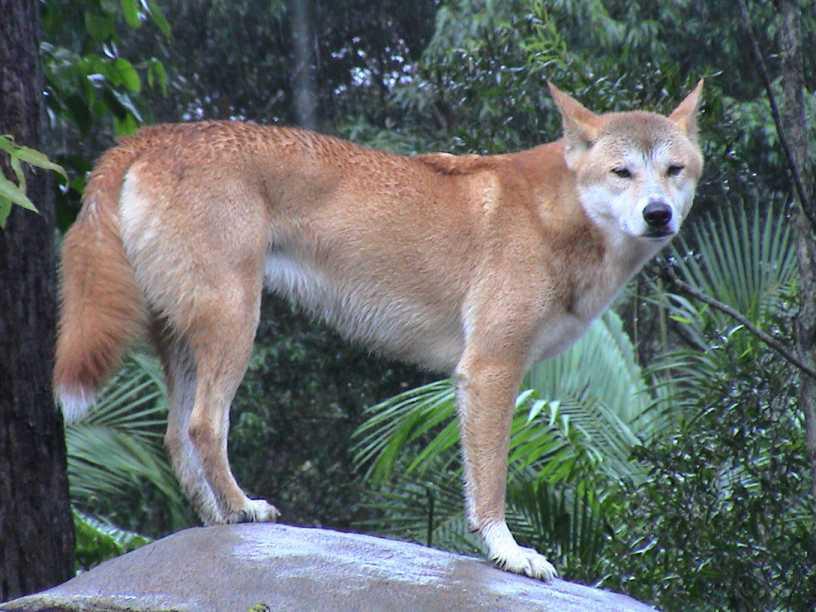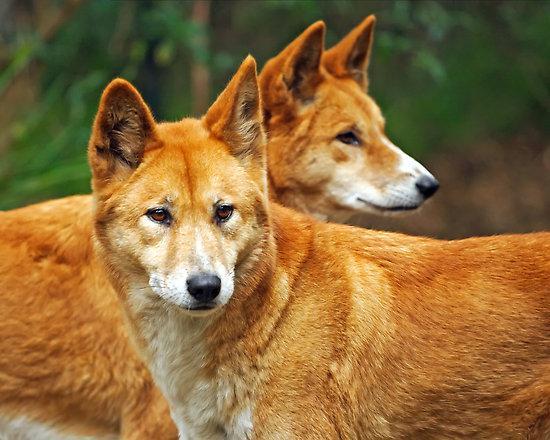The first image is the image on the left, the second image is the image on the right. Given the left and right images, does the statement "The dog in the left image stands on a rock, body in profile turned rightward." hold true? Answer yes or no. Yes. The first image is the image on the left, the second image is the image on the right. For the images displayed, is the sentence "There are two dogs, and neither of them is looking to the left." factually correct? Answer yes or no. No. 